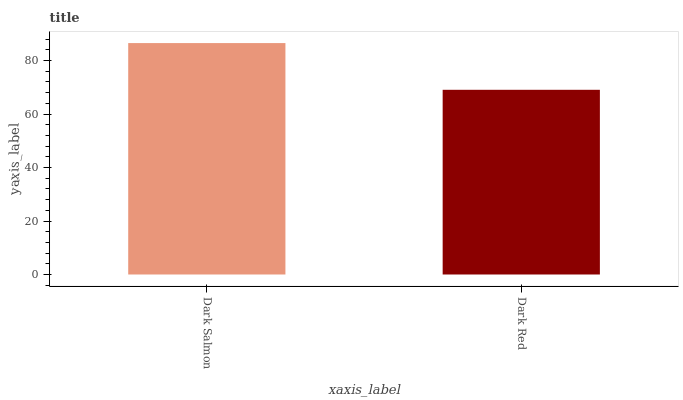Is Dark Red the minimum?
Answer yes or no. Yes. Is Dark Salmon the maximum?
Answer yes or no. Yes. Is Dark Red the maximum?
Answer yes or no. No. Is Dark Salmon greater than Dark Red?
Answer yes or no. Yes. Is Dark Red less than Dark Salmon?
Answer yes or no. Yes. Is Dark Red greater than Dark Salmon?
Answer yes or no. No. Is Dark Salmon less than Dark Red?
Answer yes or no. No. Is Dark Salmon the high median?
Answer yes or no. Yes. Is Dark Red the low median?
Answer yes or no. Yes. Is Dark Red the high median?
Answer yes or no. No. Is Dark Salmon the low median?
Answer yes or no. No. 